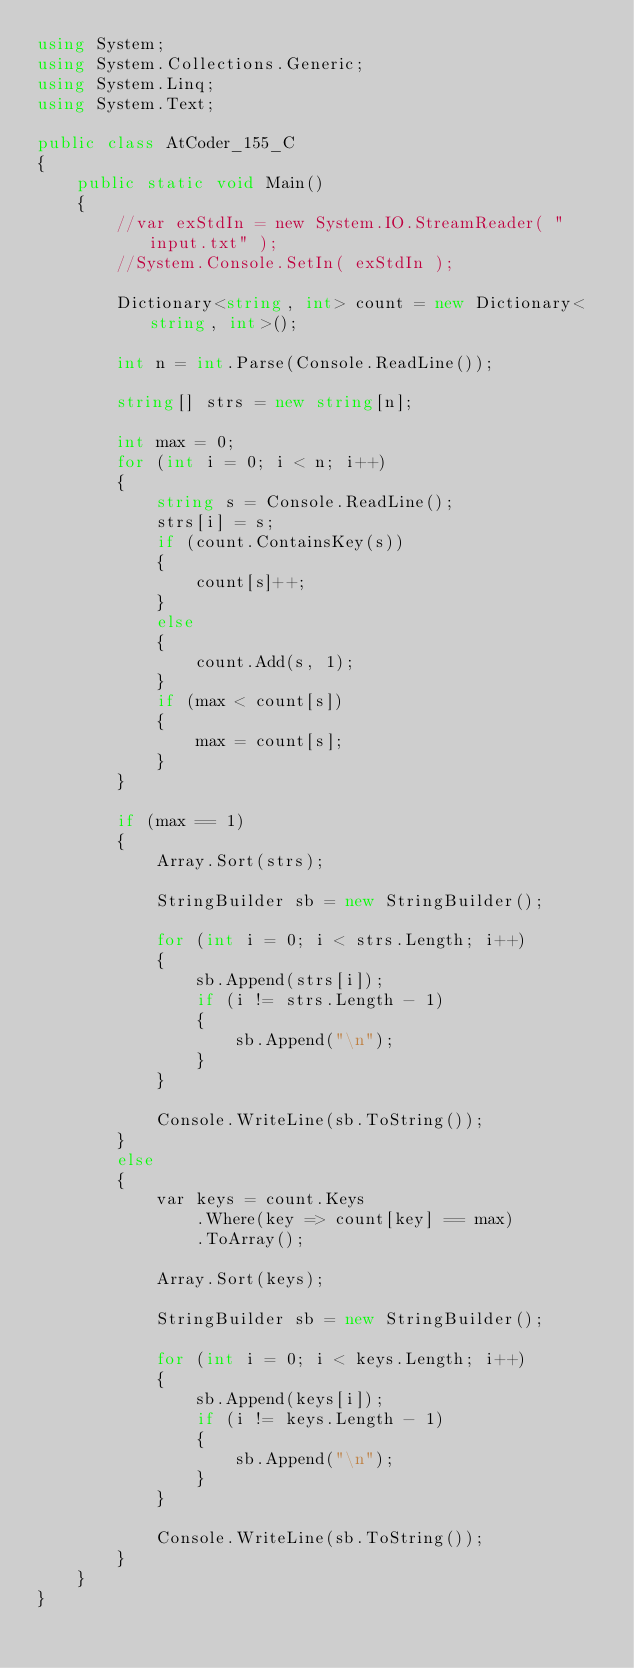Convert code to text. <code><loc_0><loc_0><loc_500><loc_500><_C#_>using System;
using System.Collections.Generic;
using System.Linq;
using System.Text;

public class AtCoder_155_C
{
    public static void Main()
    {
        //var exStdIn = new System.IO.StreamReader( "input.txt" );
        //System.Console.SetIn( exStdIn );

        Dictionary<string, int> count = new Dictionary<string, int>();

        int n = int.Parse(Console.ReadLine());

        string[] strs = new string[n];

        int max = 0;
        for (int i = 0; i < n; i++)
        {
            string s = Console.ReadLine();
            strs[i] = s;
            if (count.ContainsKey(s))
            {
                count[s]++;
            }
            else
            {
                count.Add(s, 1);
            }
            if (max < count[s])
            {
                max = count[s];
            }
        }

        if (max == 1)
        {
            Array.Sort(strs);

            StringBuilder sb = new StringBuilder();

            for (int i = 0; i < strs.Length; i++)
            {
                sb.Append(strs[i]);
                if (i != strs.Length - 1)
                {
                    sb.Append("\n");
                }
            }

            Console.WriteLine(sb.ToString());
        }
        else
        {
            var keys = count.Keys
                .Where(key => count[key] == max)
                .ToArray();

            Array.Sort(keys);

            StringBuilder sb = new StringBuilder();

            for (int i = 0; i < keys.Length; i++)
            {
                sb.Append(keys[i]);
                if (i != keys.Length - 1)
                {
                    sb.Append("\n");
                }
            }

            Console.WriteLine(sb.ToString());
        }
    }
}
</code> 